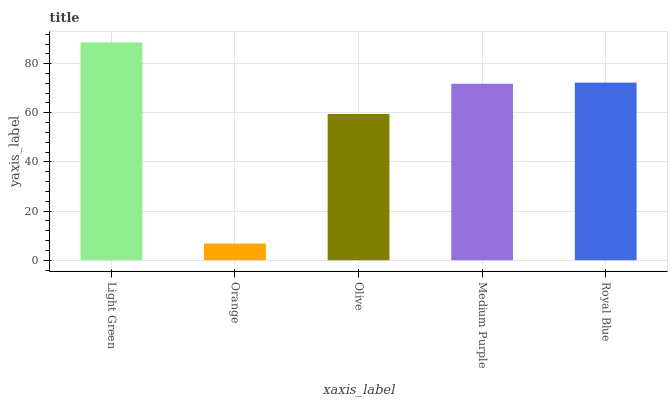Is Orange the minimum?
Answer yes or no. Yes. Is Light Green the maximum?
Answer yes or no. Yes. Is Olive the minimum?
Answer yes or no. No. Is Olive the maximum?
Answer yes or no. No. Is Olive greater than Orange?
Answer yes or no. Yes. Is Orange less than Olive?
Answer yes or no. Yes. Is Orange greater than Olive?
Answer yes or no. No. Is Olive less than Orange?
Answer yes or no. No. Is Medium Purple the high median?
Answer yes or no. Yes. Is Medium Purple the low median?
Answer yes or no. Yes. Is Light Green the high median?
Answer yes or no. No. Is Olive the low median?
Answer yes or no. No. 